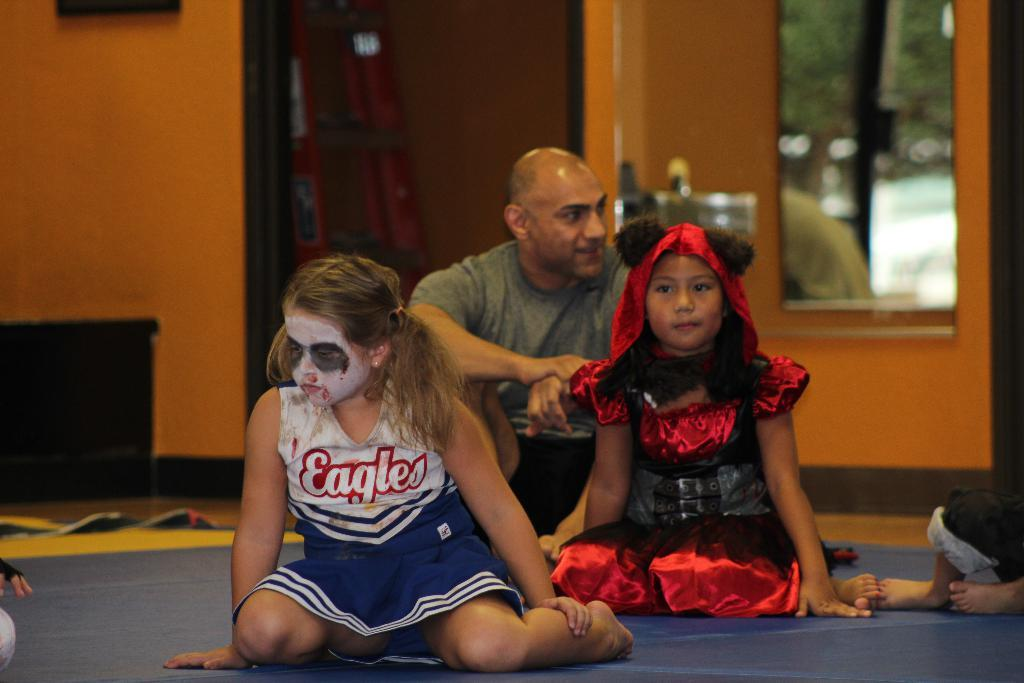<image>
Create a compact narrative representing the image presented. Girl with face paint and an Eagles jersey looking sad. 